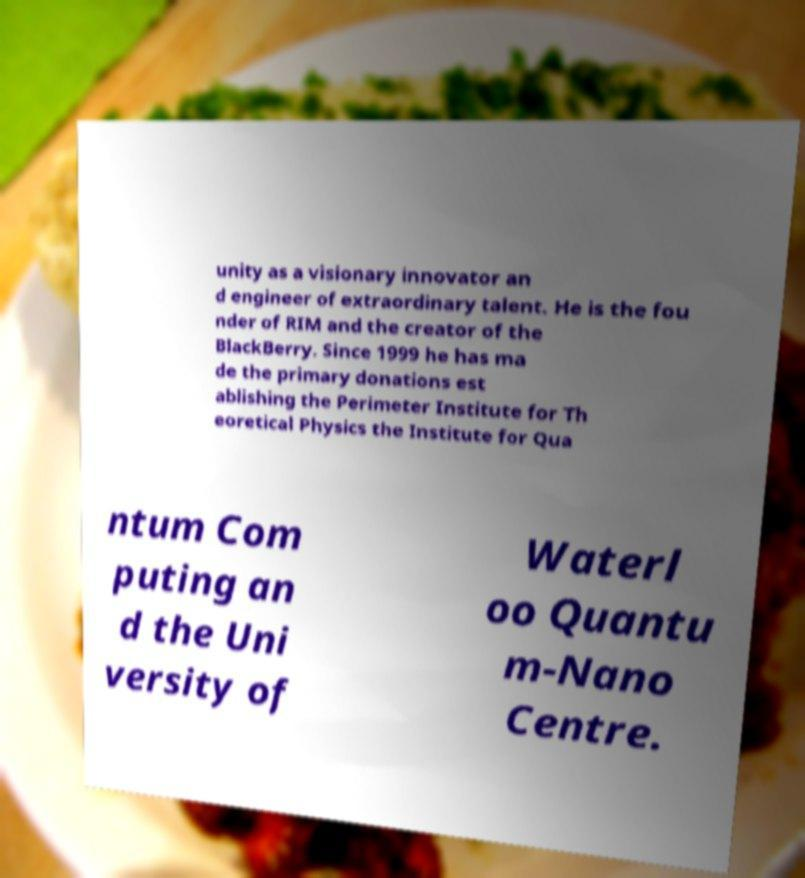What messages or text are displayed in this image? I need them in a readable, typed format. unity as a visionary innovator an d engineer of extraordinary talent. He is the fou nder of RIM and the creator of the BlackBerry. Since 1999 he has ma de the primary donations est ablishing the Perimeter Institute for Th eoretical Physics the Institute for Qua ntum Com puting an d the Uni versity of Waterl oo Quantu m-Nano Centre. 